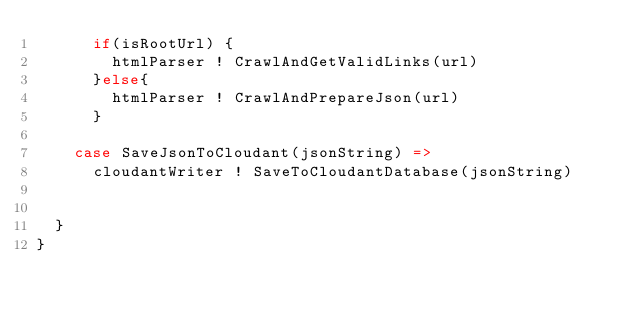Convert code to text. <code><loc_0><loc_0><loc_500><loc_500><_Scala_>      if(isRootUrl) {
        htmlParser ! CrawlAndGetValidLinks(url)
      }else{
        htmlParser ! CrawlAndPrepareJson(url)
      }

    case SaveJsonToCloudant(jsonString) =>
      cloudantWriter ! SaveToCloudantDatabase(jsonString)


  }
}
</code> 